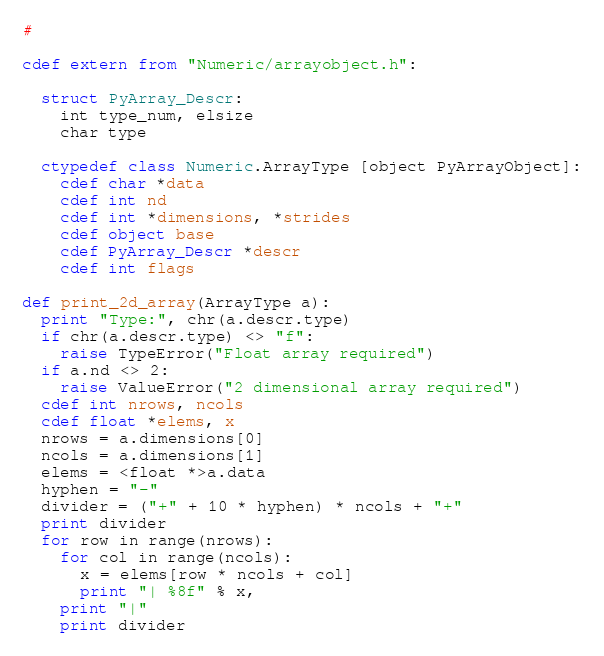<code> <loc_0><loc_0><loc_500><loc_500><_Cython_>#

cdef extern from "Numeric/arrayobject.h":

  struct PyArray_Descr:
    int type_num, elsize
    char type

  ctypedef class Numeric.ArrayType [object PyArrayObject]:
    cdef char *data
    cdef int nd
    cdef int *dimensions, *strides
    cdef object base
    cdef PyArray_Descr *descr
    cdef int flags

def print_2d_array(ArrayType a):
  print "Type:", chr(a.descr.type)
  if chr(a.descr.type) <> "f":
    raise TypeError("Float array required")
  if a.nd <> 2:
    raise ValueError("2 dimensional array required")
  cdef int nrows, ncols
  cdef float *elems, x
  nrows = a.dimensions[0]
  ncols = a.dimensions[1]
  elems = <float *>a.data
  hyphen = "-"
  divider = ("+" + 10 * hyphen) * ncols + "+"
  print divider
  for row in range(nrows):
    for col in range(ncols):
      x = elems[row * ncols + col]
      print "| %8f" % x,
    print "|"
    print divider
</code> 